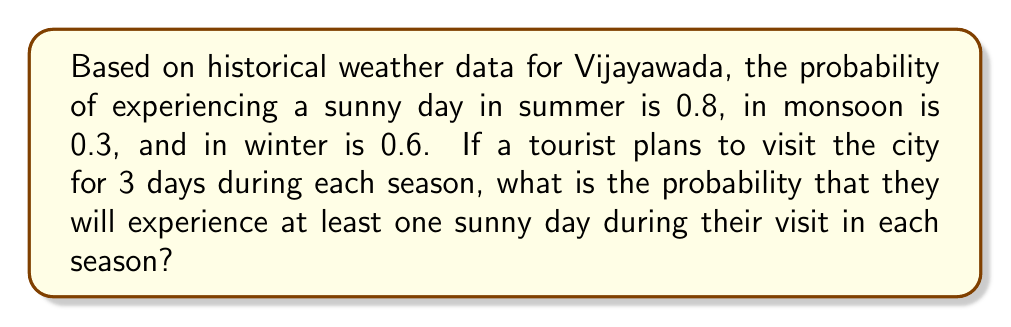Can you solve this math problem? Let's approach this step-by-step:

1) First, we need to calculate the probability of not having a sunny day for each season:
   Summer: $1 - 0.8 = 0.2$
   Monsoon: $1 - 0.3 = 0.7$
   Winter: $1 - 0.6 = 0.4$

2) Now, we calculate the probability of not having any sunny days during the 3-day visit for each season:
   Summer: $0.2^3 = 0.008$
   Monsoon: $0.7^3 = 0.343$
   Winter: $0.4^3 = 0.064$

3) The probability of having at least one sunny day is the complement of having no sunny days:
   Summer: $1 - 0.008 = 0.992$
   Monsoon: $1 - 0.343 = 0.657$
   Winter: $1 - 0.064 = 0.936$

4) To find the probability of experiencing at least one sunny day in each season, we multiply these probabilities:

   $$P(\text{at least one sunny day in each season}) = 0.992 \times 0.657 \times 0.936$$

5) Calculating this:
   $$0.992 \times 0.657 \times 0.936 = 0.6098$$

Therefore, the probability of experiencing at least one sunny day during the 3-day visit in each of the three seasons is approximately 0.6098 or 60.98%.
Answer: $0.6098$ or $60.98\%$ 